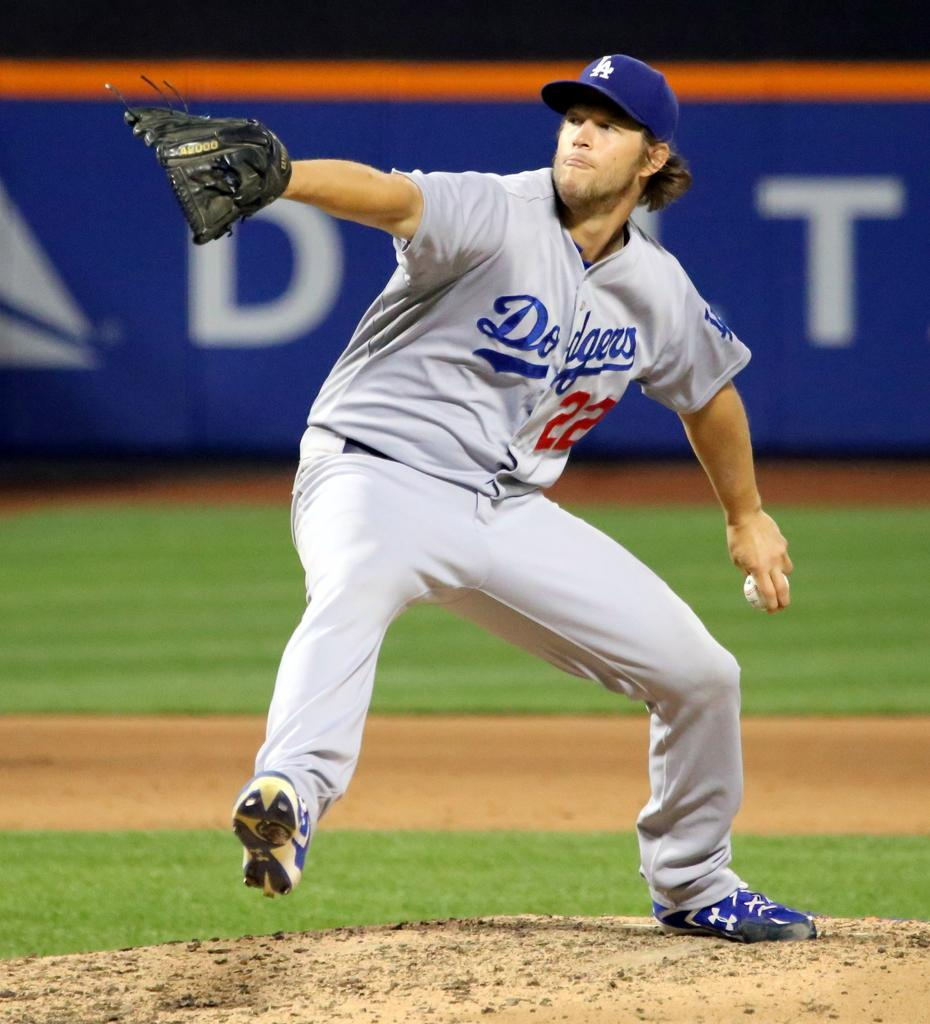<image>
Write a terse but informative summary of the picture. An LA Dodgers player getting ready to throw a pitch. 